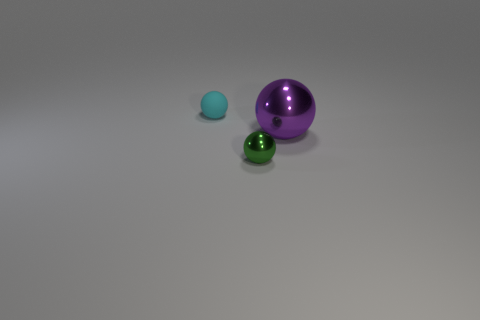There is a sphere on the left side of the metallic thing that is left of the big metal object; how big is it?
Your answer should be compact. Small. What number of big objects are either blue rubber things or balls?
Ensure brevity in your answer.  1. Are there fewer small matte objects than things?
Make the answer very short. Yes. Are there any other things that have the same size as the purple ball?
Your response must be concise. No. Is the number of purple shiny spheres greater than the number of small blue things?
Provide a short and direct response. Yes. What number of other objects are the same color as the tiny shiny thing?
Give a very brief answer. 0. There is a tiny object that is in front of the tiny cyan matte sphere; how many balls are left of it?
Make the answer very short. 1. Are there any big shiny things to the right of the small green shiny sphere?
Offer a very short reply. Yes. The tiny object on the right side of the small ball that is left of the green metal thing is what shape?
Your answer should be very brief. Sphere. Is the number of matte balls that are in front of the green metal ball less than the number of metallic balls that are behind the big metallic ball?
Provide a succinct answer. No. 